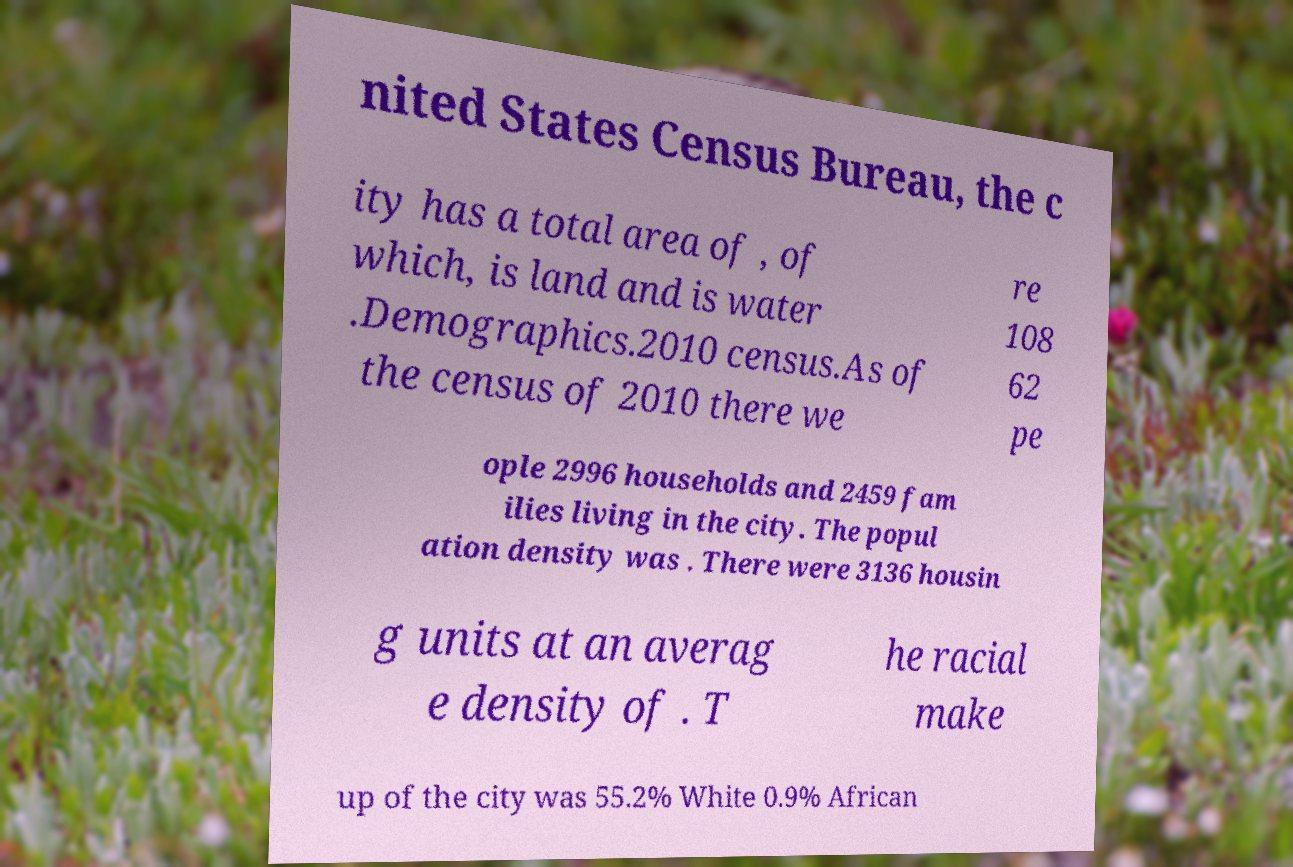Can you accurately transcribe the text from the provided image for me? nited States Census Bureau, the c ity has a total area of , of which, is land and is water .Demographics.2010 census.As of the census of 2010 there we re 108 62 pe ople 2996 households and 2459 fam ilies living in the city. The popul ation density was . There were 3136 housin g units at an averag e density of . T he racial make up of the city was 55.2% White 0.9% African 